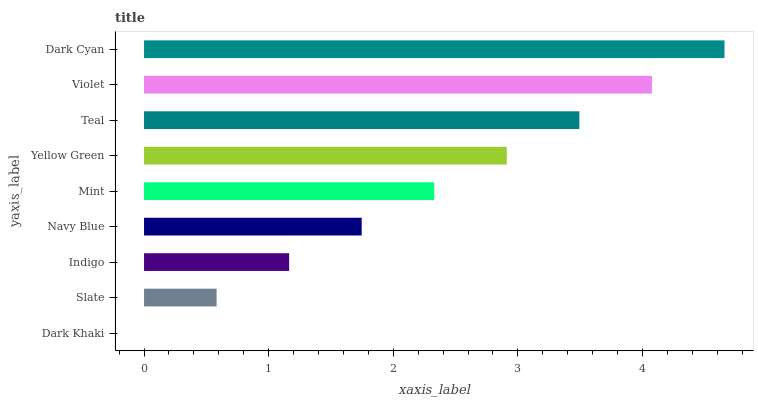Is Dark Khaki the minimum?
Answer yes or no. Yes. Is Dark Cyan the maximum?
Answer yes or no. Yes. Is Slate the minimum?
Answer yes or no. No. Is Slate the maximum?
Answer yes or no. No. Is Slate greater than Dark Khaki?
Answer yes or no. Yes. Is Dark Khaki less than Slate?
Answer yes or no. Yes. Is Dark Khaki greater than Slate?
Answer yes or no. No. Is Slate less than Dark Khaki?
Answer yes or no. No. Is Mint the high median?
Answer yes or no. Yes. Is Mint the low median?
Answer yes or no. Yes. Is Dark Khaki the high median?
Answer yes or no. No. Is Teal the low median?
Answer yes or no. No. 